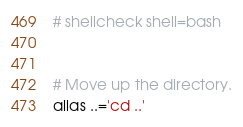Convert code to text. <code><loc_0><loc_0><loc_500><loc_500><_Bash_># shellcheck shell=bash


# Move up the directory.
alias ..='cd ..'</code> 